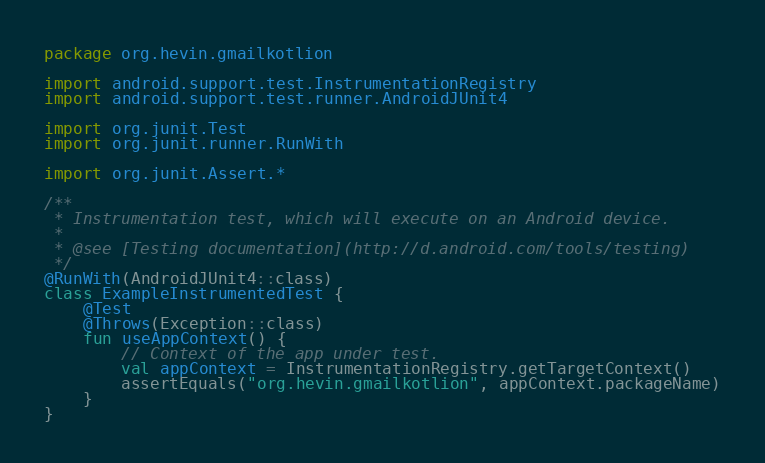Convert code to text. <code><loc_0><loc_0><loc_500><loc_500><_Kotlin_>package org.hevin.gmailkotlion

import android.support.test.InstrumentationRegistry
import android.support.test.runner.AndroidJUnit4

import org.junit.Test
import org.junit.runner.RunWith

import org.junit.Assert.*

/**
 * Instrumentation test, which will execute on an Android device.
 *
 * @see [Testing documentation](http://d.android.com/tools/testing)
 */
@RunWith(AndroidJUnit4::class)
class ExampleInstrumentedTest {
    @Test
    @Throws(Exception::class)
    fun useAppContext() {
        // Context of the app under test.
        val appContext = InstrumentationRegistry.getTargetContext()
        assertEquals("org.hevin.gmailkotlion", appContext.packageName)
    }
}
</code> 